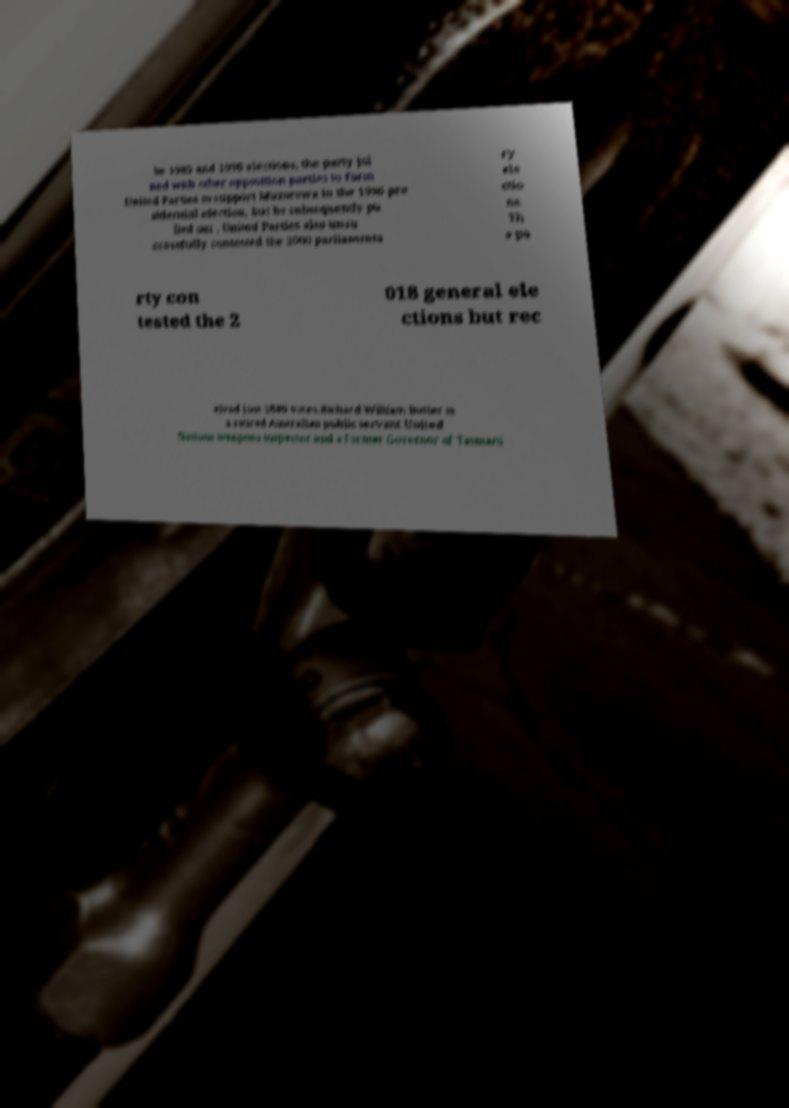Please read and relay the text visible in this image. What does it say? he 1985 and 1990 elections, the party joi ned with other opposition parties to form United Parties to support Muzorewa in the 1996 pre sidential election, but he subsequently pu lled out . United Parties also unsu ccessfully contested the 2000 parliamenta ry ele ctio ns. Th e pa rty con tested the 2 018 general ele ctions but rec eived just 1889 votes.Richard William Butler is a retired Australian public servant United Nations weapons inspector and a former Governor of Tasmani 